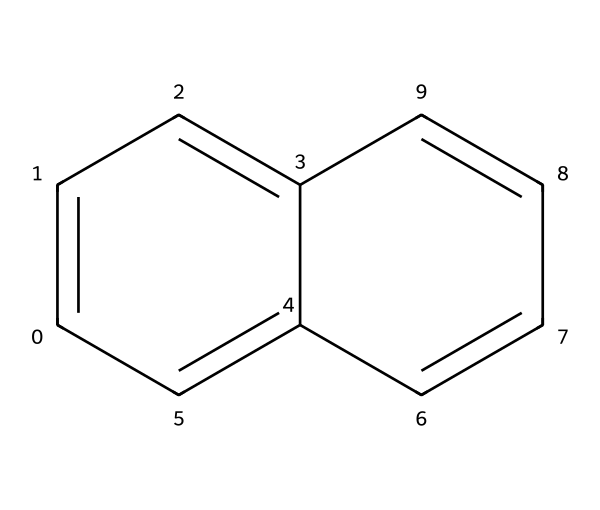What type of chemical compound is represented in the SMILES? The SMILES represents an organic compound, specifically a polycyclic aromatic hydrocarbon due to the ring structures and alternating double bonds.
Answer: organic compound How many rings are present in this chemical structure? The structure shows two fused rings, indicating that there are two rings present in the chemical.
Answer: two How many carbon atoms are in this compound? By analyzing the structure, we can count a total of 12 carbon atoms connected in the rings.
Answer: twelve What kind of applications might this chemical have in calligraphy? Polycyclic aromatic hydrocarbons are often used in dyes and pigments for inks due to their stability and color properties, making them suitable for calligraphy.
Answer: dyes Is the compound likely to be soluble in water? Due to its hydrophobic nature (as most polycyclic aromatic hydrocarbons are), it is likely to have low solubility in water.
Answer: low Does this compound contain any heteroatoms? Looking at the SMILES, there are no heteroatoms present, indicating that the compound is solely composed of carbon and hydrogen.
Answer: no 